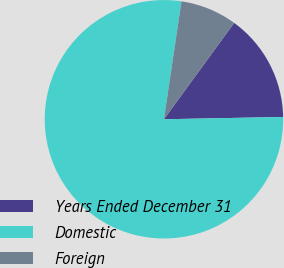<chart> <loc_0><loc_0><loc_500><loc_500><pie_chart><fcel>Years Ended December 31<fcel>Domestic<fcel>Foreign<nl><fcel>14.67%<fcel>77.66%<fcel>7.67%<nl></chart> 